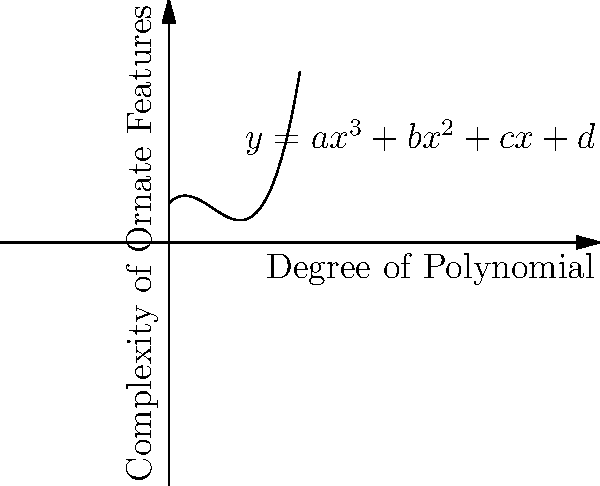In religious architectural design, the complexity of ornate features often correlates with the degree of the polynomial used to model them. Consider the polynomial function $y = ax^3 + bx^2 + cx + d$, where $y$ represents the complexity of ornate features and $x$ represents the degree of the polynomial. If $a = 0.05$, $b = -0.5$, $c = 1$, and $d = 3$, at what degree (x-value) does the complexity of ornate features reach its minimum? To find the minimum point of the function, we need to follow these steps:

1) The given function is $y = 0.05x^3 - 0.5x^2 + x + 3$

2) To find the minimum, we need to find where the derivative equals zero:
   $\frac{dy}{dx} = 0.15x^2 - x + 1 = 0$

3) This is a quadratic equation. We can solve it using the quadratic formula:
   $x = \frac{-b \pm \sqrt{b^2 - 4ac}}{2a}$

   Where $a = 0.15$, $b = -1$, and $c = 1$

4) Plugging in these values:
   $x = \frac{1 \pm \sqrt{1 - 4(0.15)(1)}}{2(0.15)}$
   $= \frac{1 \pm \sqrt{0.4}}{0.3}$

5) This gives us two solutions:
   $x_1 = \frac{1 + \sqrt{0.4}}{0.3} \approx 5.44$
   $x_2 = \frac{1 - \sqrt{0.4}}{0.3} \approx 1.22$

6) The smaller value, $x_2 \approx 1.22$, corresponds to the minimum point.

Therefore, the complexity of ornate features reaches its minimum when the degree of the polynomial is approximately 1.22.
Answer: $1.22$ 